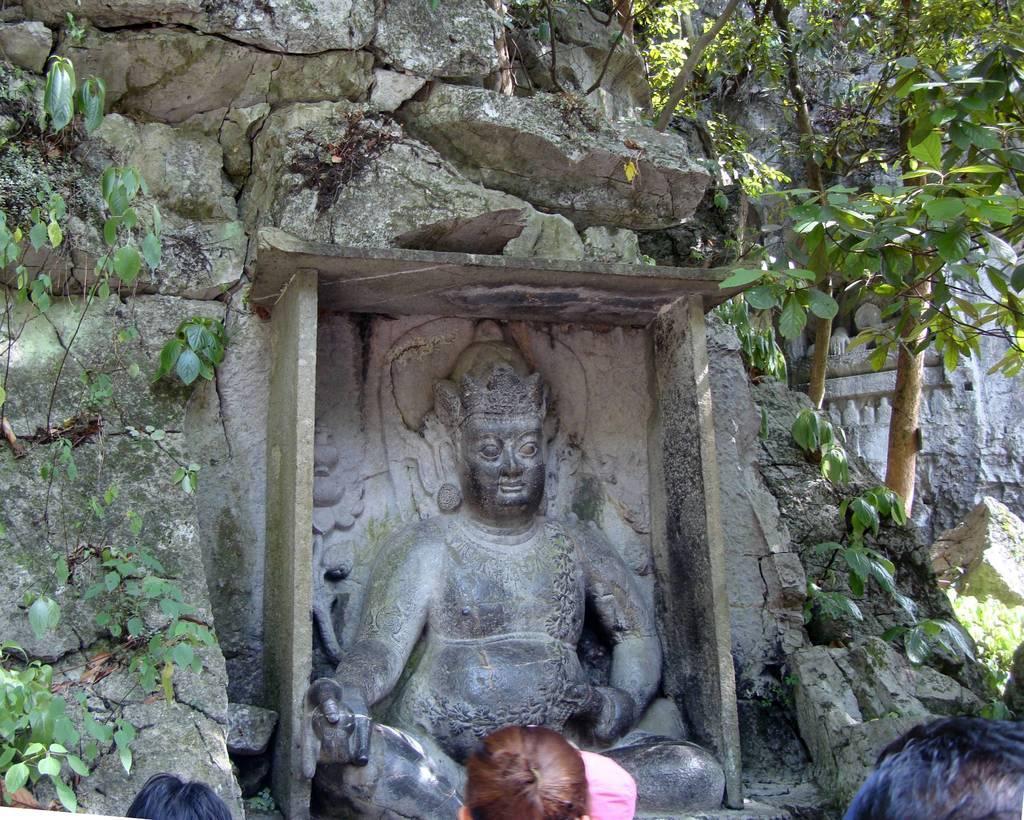Please provide a concise description of this image. In this image, I can see the sculptures. These are the rocks. I can see the trees. At the bottom of the image, I can see the heads of the people. 